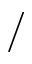Convert formula to latex. <formula><loc_0><loc_0><loc_500><loc_500>/</formula> 